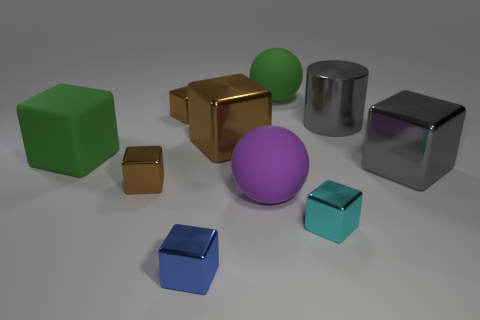Subtract all small blue cubes. How many cubes are left? 6 Subtract all red spheres. How many brown blocks are left? 3 Subtract 5 blocks. How many blocks are left? 2 Subtract all blue cubes. How many cubes are left? 6 Subtract all purple cubes. Subtract all blue balls. How many cubes are left? 7 Subtract 0 red balls. How many objects are left? 10 Subtract all spheres. How many objects are left? 8 Subtract all big brown objects. Subtract all tiny cyan cubes. How many objects are left? 8 Add 1 green rubber balls. How many green rubber balls are left? 2 Add 9 yellow blocks. How many yellow blocks exist? 9 